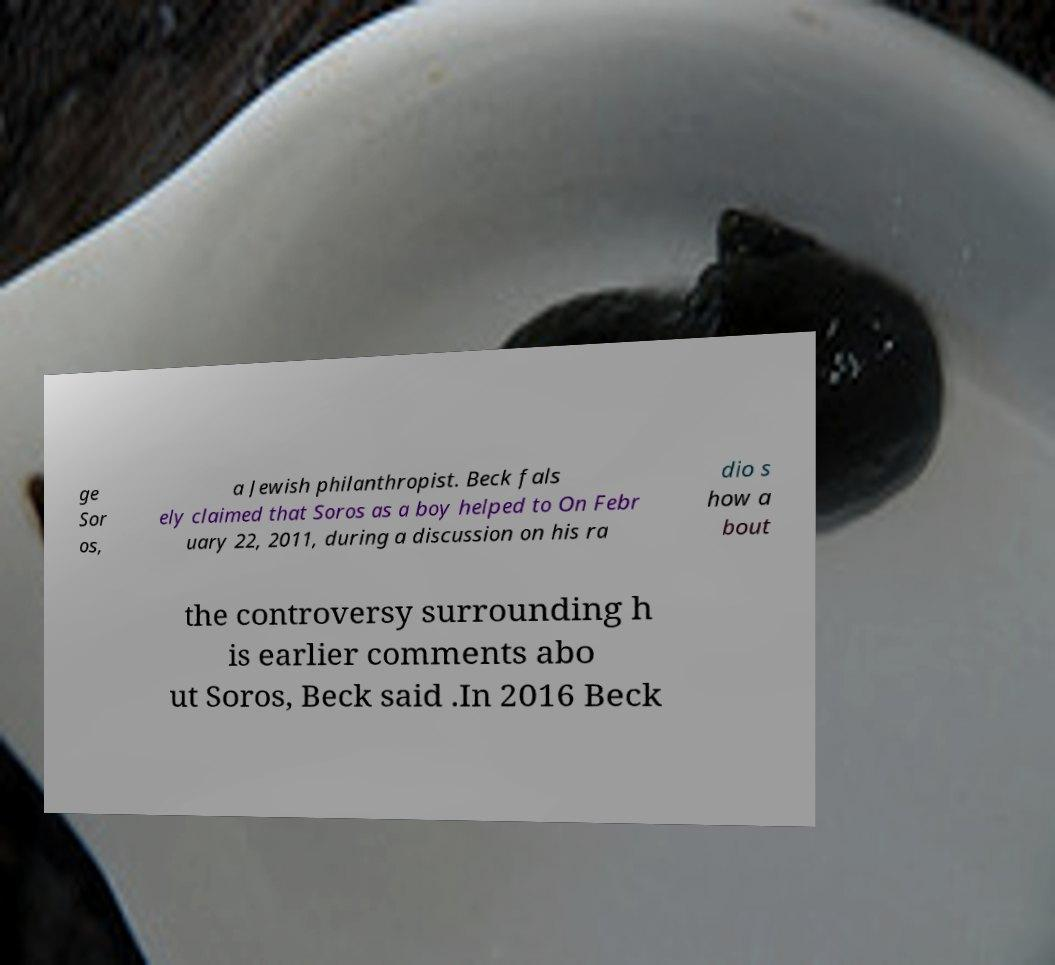Can you read and provide the text displayed in the image?This photo seems to have some interesting text. Can you extract and type it out for me? ge Sor os, a Jewish philanthropist. Beck fals ely claimed that Soros as a boy helped to On Febr uary 22, 2011, during a discussion on his ra dio s how a bout the controversy surrounding h is earlier comments abo ut Soros, Beck said .In 2016 Beck 